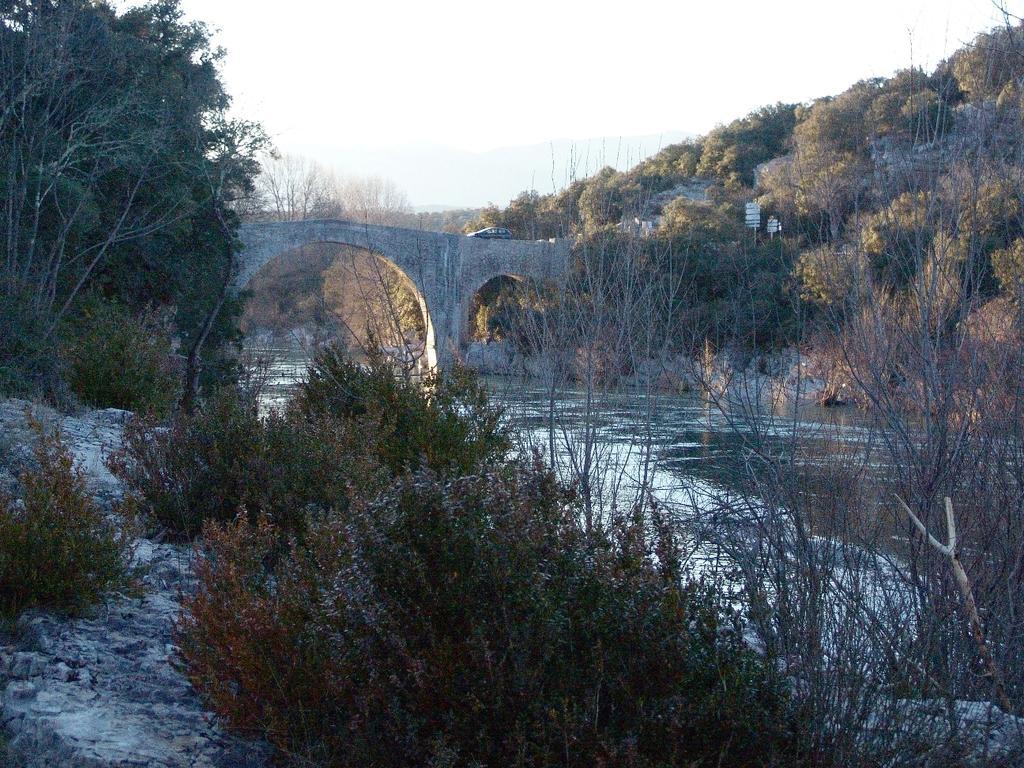In one or two sentences, can you explain what this image depicts? In this image there are trees, river and there is a vehicle moving on the bride, there are a few boards. In the background there is the sky. 